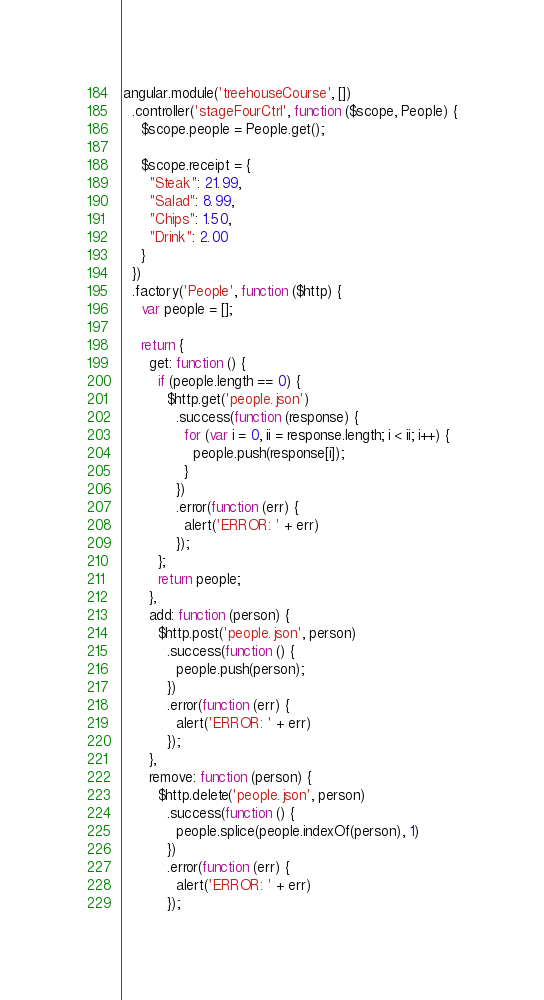Convert code to text. <code><loc_0><loc_0><loc_500><loc_500><_JavaScript_>angular.module('treehouseCourse', [])
  .controller('stageFourCtrl', function ($scope, People) {
    $scope.people = People.get();

    $scope.receipt = {
      "Steak": 21.99,
      "Salad": 8.99,
      "Chips": 1.50,
      "Drink": 2.00
    }
  })
  .factory('People', function ($http) {
    var people = [];

    return {
      get: function () {
        if (people.length == 0) {
          $http.get('people.json')
            .success(function (response) {
              for (var i = 0, ii = response.length; i < ii; i++) {
                people.push(response[i]);
              }
            })
            .error(function (err) {
              alert('ERROR: ' + err)
            });
        };
        return people;
      },
      add: function (person) {
        $http.post('people.json', person)
          .success(function () {
            people.push(person);
          })
          .error(function (err) {
            alert('ERROR: ' + err)
          });
      },
      remove: function (person) {
        $http.delete('people.json', person)
          .success(function () {
            people.splice(people.indexOf(person), 1)
          })
          .error(function (err) {
            alert('ERROR: ' + err)
          });</code> 